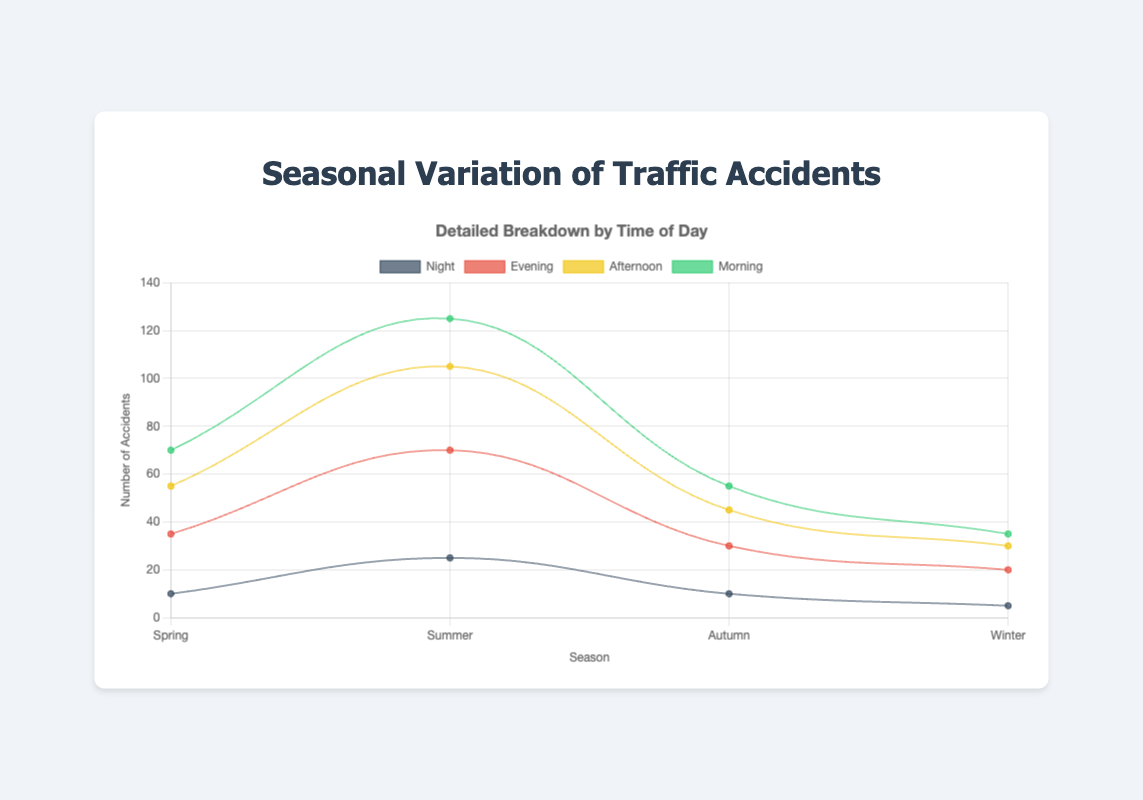Which season has the highest number of traffic accidents in the evening? To find this, look at the data points for the 'Evening' dataset across all seasons. The highest value is 45 in summer.
Answer: Summer What is the total number of traffic accidents in autumn? Sum the number of accidents in autumn for each time of day: morning (10), afternoon (15), evening (20), and night (10). The total is 10 + 15 + 20 + 10 = 55.
Answer: 55 How many more traffic accidents occur in the summer evening compared to the spring morning? Subtract the number of spring morning accidents from summer evening accidents: 45 - 15 = 30.
Answer: 30 In which season is there the smallest variation in the number of traffic accidents throughout the day? Look at the height variation among the different times of day within each season. Winter shows the smallest variation (morning: 5, afternoon: 10, evening: 15, night: 5).
Answer: Winter During which time of day do traffic accidents peak in winter? In the winter dataset, the peak (highest value) is during the evening with 15 accidents.
Answer: Evening What is the difference in traffic accidents between night-time in summer and winter? Subtract the number of nighttime accidents in winter from summer: 25 - 5 = 20.
Answer: 20 Compare the number of morning traffic accidents in spring and autumn. Which one is higher? Examine the morning dataset for both spring (15) and autumn (10). Spring has a higher number.
Answer: Spring Calculate the average number of traffic accidents across all times of day in spring. Sum the values for spring (morning: 15, afternoon: 20, evening: 25, night: 10) and divide by 4. The total is 70, and the average is 70/4 = 17.5.
Answer: 17.5 In which season do night-time accidents have the highest percentage of total daily accidents? Calculate the percentage for each season. 
For Spring: (10/70) * 100 ≈ 14% 
For Summer: (25/125) * 100 = 20% 
For Autumn: (10/55) * 100 ≈ 18% 
For Winter: (5/35) * 100 ≈ 14%. 
Summer has the highest percentage.
Answer: Summer Which time of day sees the most significant increase in traffic accidents from winter to summer? Calculate the increase for each time of day:
Morning: 20 - 5 = 15
Afternoon: 35 - 10 = 25
Evening: 45 - 15 = 30
Night: 25 - 5 = 20
The largest increase is for evening with 30.
Answer: Evening 